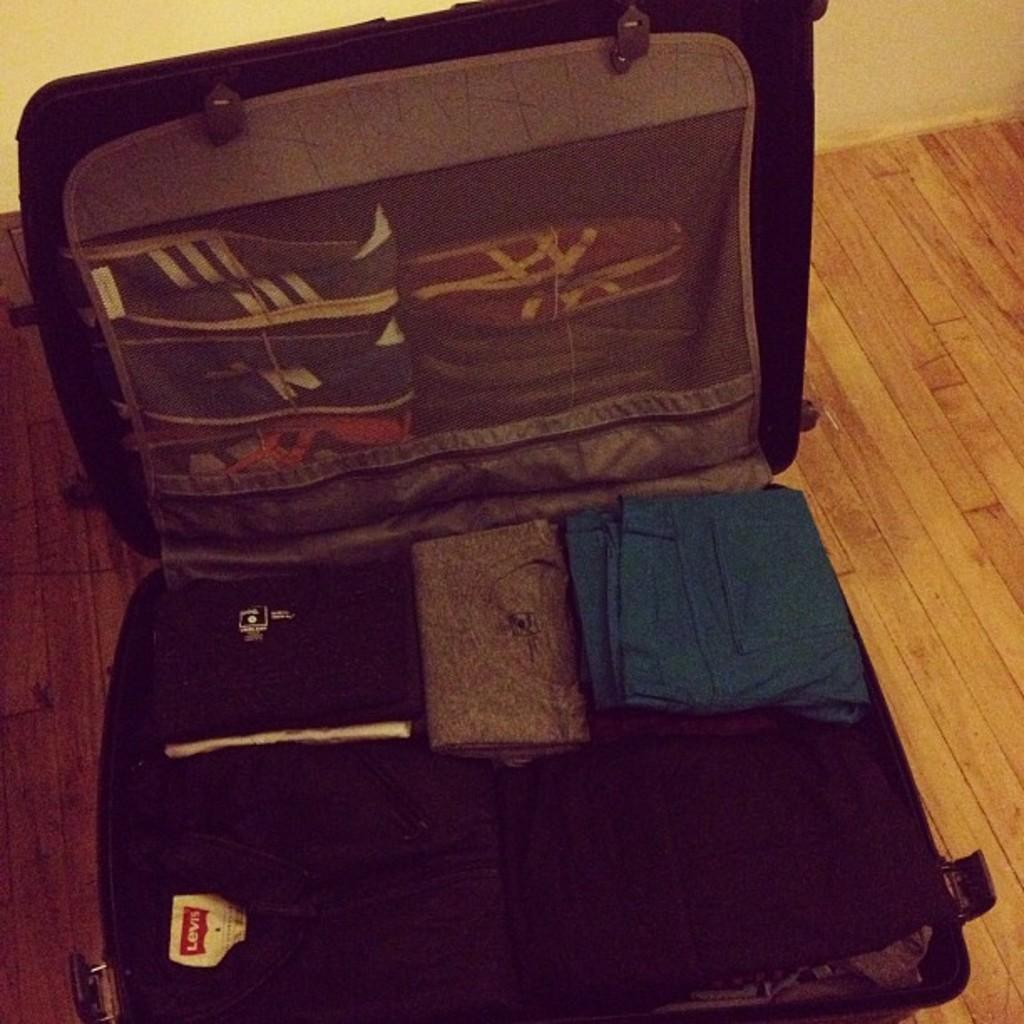What is the setting of the image? The image is inside a luggage bag. What can be found inside the luggage bag? There are clothes in the luggage bag. Where is the luggage bag located? The luggage bag is placed on the floor. Is there a volcano erupting inside the luggage bag in the image? No, there is no volcano present in the image. How many ladybugs can be seen crawling on the clothes in the luggage bag? There are no ladybugs visible in the image. 